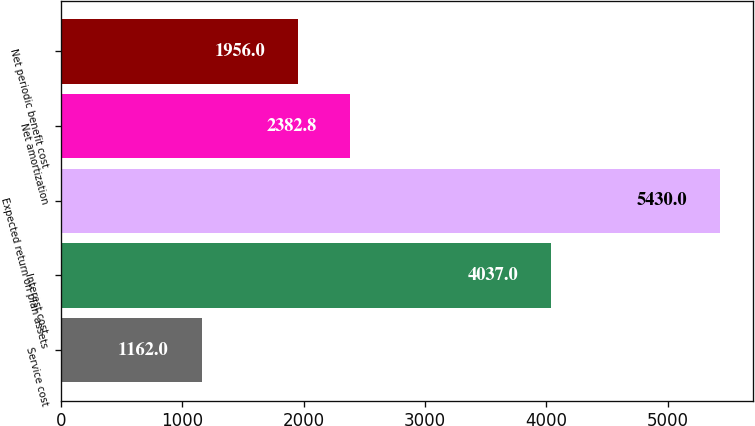Convert chart to OTSL. <chart><loc_0><loc_0><loc_500><loc_500><bar_chart><fcel>Service cost<fcel>Interest cost<fcel>Expected return on plan assets<fcel>Net amortization<fcel>Net periodic benefit cost<nl><fcel>1162<fcel>4037<fcel>5430<fcel>2382.8<fcel>1956<nl></chart> 